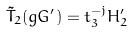Convert formula to latex. <formula><loc_0><loc_0><loc_500><loc_500>\tilde { T } _ { 2 } ( g G ^ { \prime } ) = t _ { 3 } ^ { - j } H _ { 2 } ^ { \prime }</formula> 